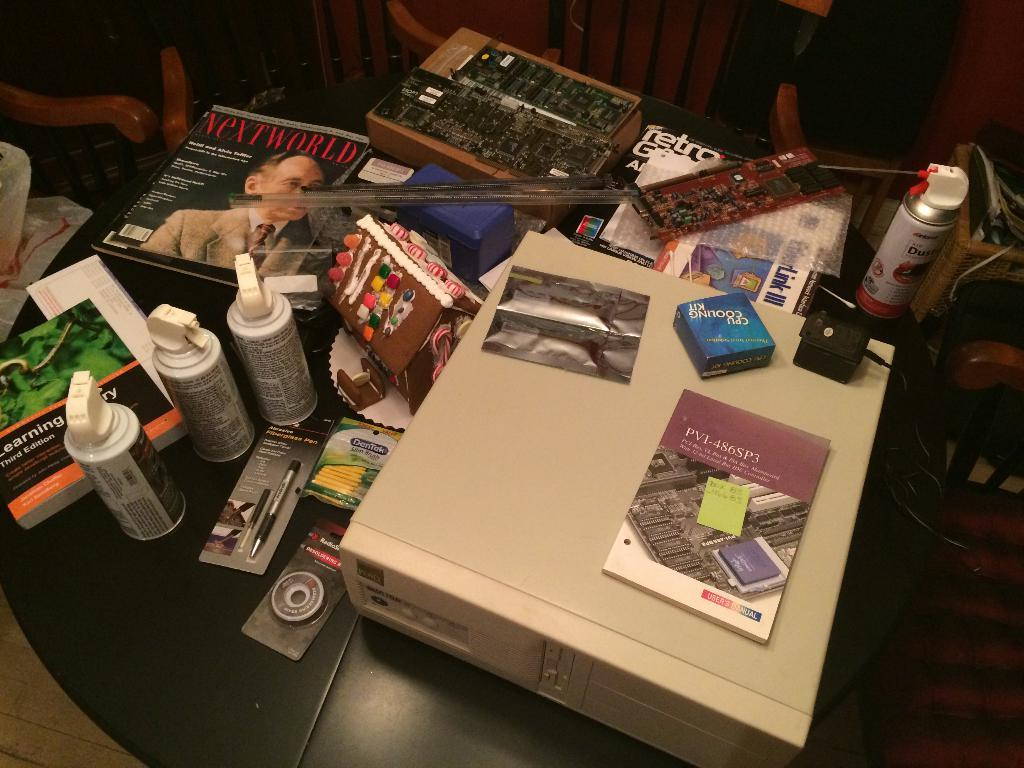What type of objects can be seen in the image that are related to electronics? There are electronic things in the image, but the specific items are not mentioned. What type of objects can be seen in the image that are used for storage? There are boxes in the image. What type of objects can be seen in the image that are used for reading or learning? There are books in the image. What type of objects can be seen in the image that are used for spraying substances? There are spray cans in the image. What type of object can be seen in the image that is used for writing? There is a pen in the image. What type of objects can be seen in the image that are used for sitting? There are chairs in the image. How does the pest affect the electronic things in the image? There is no mention of a pest in the image, so it cannot affect the electronic things. What type of notebook is used for writing in the image? There is no notebook present in the image. 